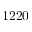<formula> <loc_0><loc_0><loc_500><loc_500>1 2 2 0</formula> 